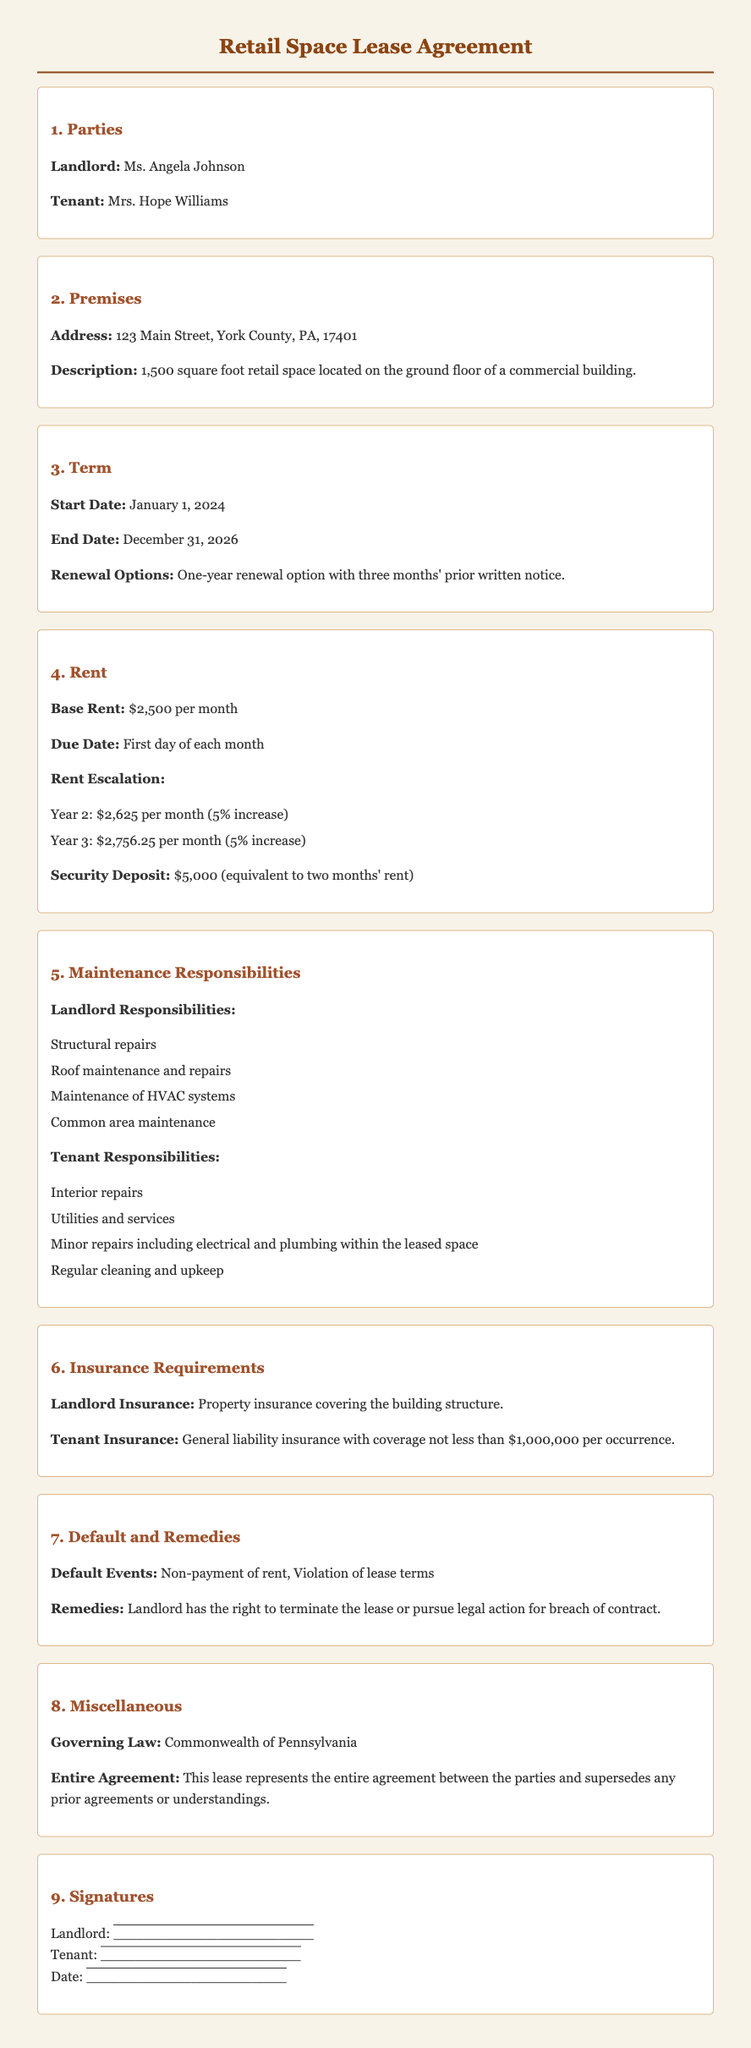what is the address of the retail space? The address is listed under the Premises section, specifying the location of the retail space.
Answer: 123 Main Street, York County, PA, 17401 who is the landlord? The Landlord's name is stated at the beginning of the document as part of the parties involved.
Answer: Ms. Angela Johnson what is the base rent for the retail space? The Base Rent is specified in the Rent section of the document, which states the amount due each month.
Answer: $2,500 per month what is the security deposit amount? The security deposit is highlighted in the Rent section as a requirement by the landlord.
Answer: $5,000 what are the tenant's responsibilities regarding repairs? Tenant responsibilities are mentioned in the Maintenance Responsibilities section, outlining what the tenant is responsible for.
Answer: Interior repairs, Utilities and services, Minor repairs including electrical and plumbing within the leased space, Regular cleaning and upkeep how long is the lease term? The lease term is given in the Term section, specifying the start and end dates clearly.
Answer: Three years what is the rent escalation for year 2? The document specifies the rent escalation amounts for each year, which are listed in the Rent section.
Answer: $2,625 per month what type of insurance is required for the tenant? The Insurance Requirements section specifies the type of insurance that the tenant must carry.
Answer: General liability insurance with coverage not less than $1,000,000 per occurrence 